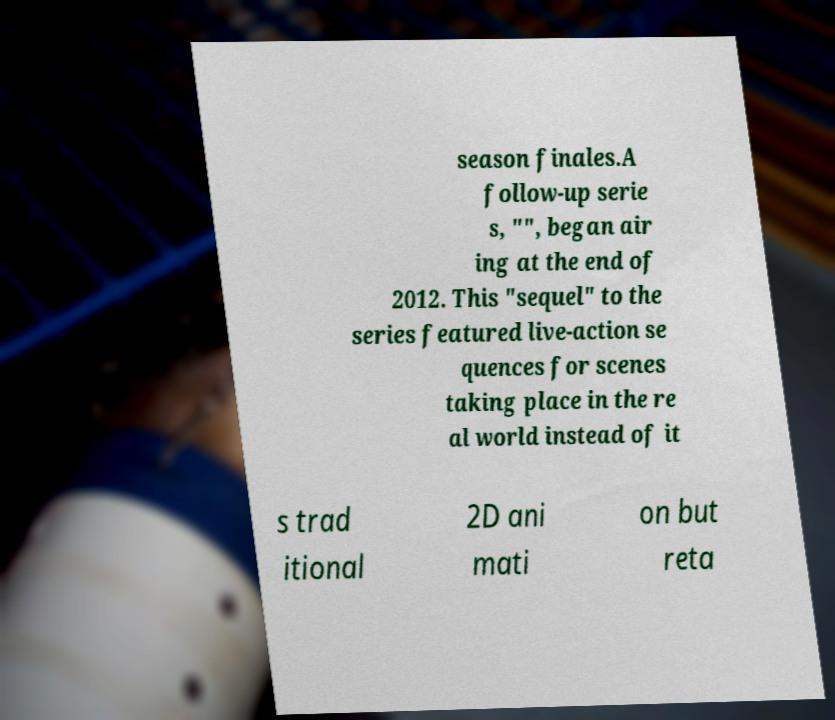There's text embedded in this image that I need extracted. Can you transcribe it verbatim? season finales.A follow-up serie s, "", began air ing at the end of 2012. This "sequel" to the series featured live-action se quences for scenes taking place in the re al world instead of it s trad itional 2D ani mati on but reta 